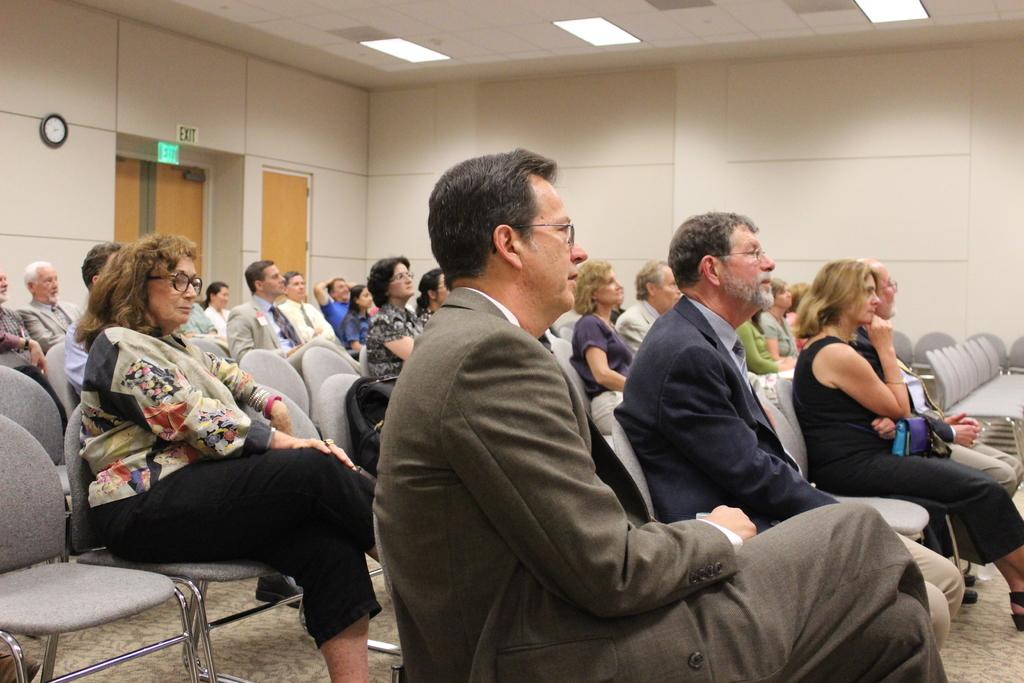What is happening in the image involving a group of people? There is a group of people in the image, and they are sitting on chairs. What are the people doing while sitting on the chairs? The people are listening to a speech. What type of table is being exchanged between the people in the image? There is no table present in the image, nor is there any indication of an exchange taking place. 